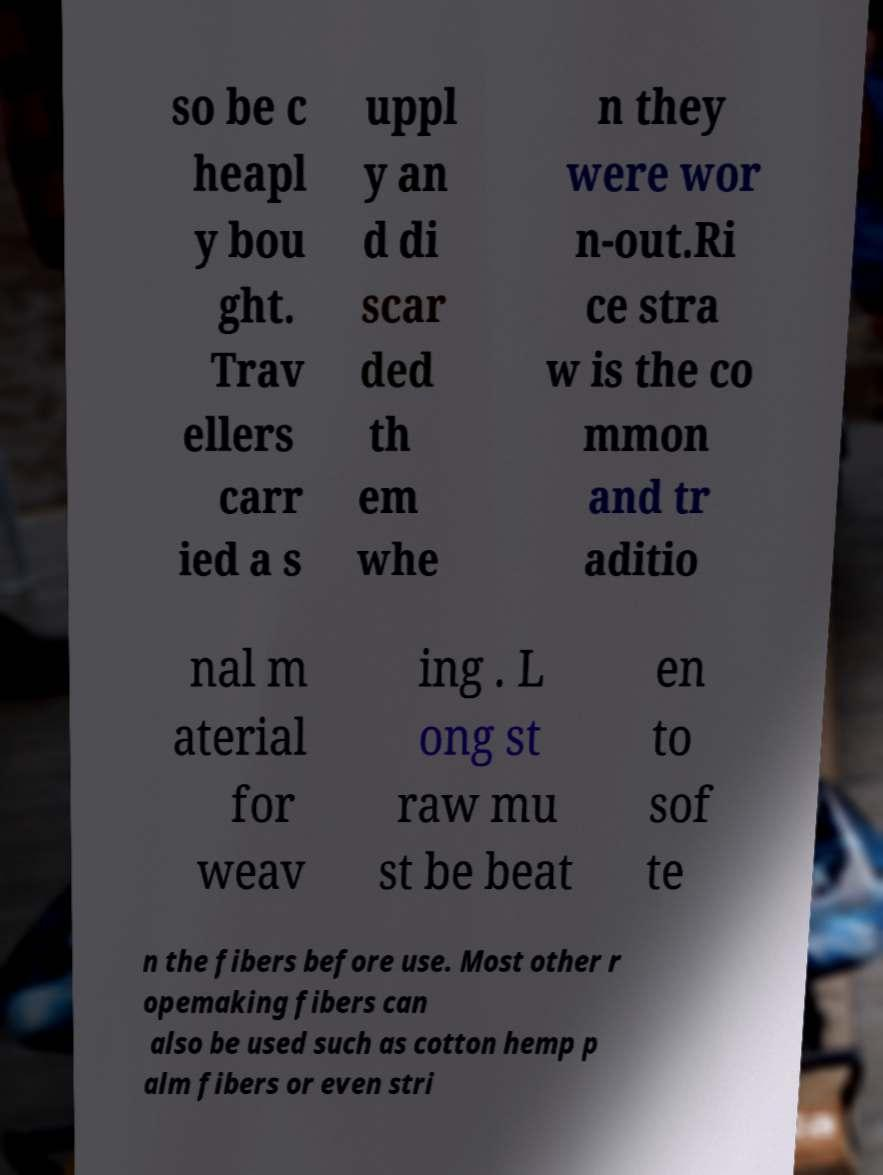Could you assist in decoding the text presented in this image and type it out clearly? so be c heapl y bou ght. Trav ellers carr ied a s uppl y an d di scar ded th em whe n they were wor n-out.Ri ce stra w is the co mmon and tr aditio nal m aterial for weav ing . L ong st raw mu st be beat en to sof te n the fibers before use. Most other r opemaking fibers can also be used such as cotton hemp p alm fibers or even stri 